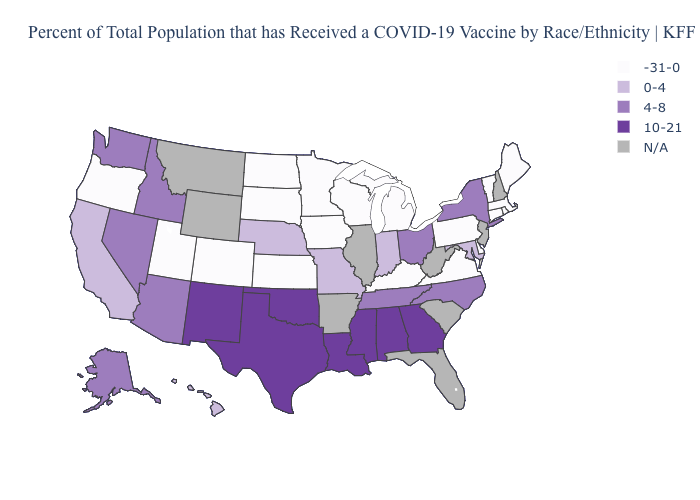Name the states that have a value in the range 4-8?
Answer briefly. Alaska, Arizona, Idaho, Nevada, New York, North Carolina, Ohio, Tennessee, Washington. How many symbols are there in the legend?
Give a very brief answer. 5. What is the value of Michigan?
Quick response, please. -31-0. Does Colorado have the lowest value in the USA?
Concise answer only. Yes. Among the states that border New Hampshire , which have the highest value?
Write a very short answer. Maine, Massachusetts, Vermont. How many symbols are there in the legend?
Keep it brief. 5. Name the states that have a value in the range N/A?
Be succinct. Arkansas, Florida, Illinois, Montana, New Hampshire, New Jersey, South Carolina, West Virginia, Wyoming. Does Kansas have the highest value in the USA?
Write a very short answer. No. Name the states that have a value in the range -31-0?
Keep it brief. Colorado, Connecticut, Delaware, Iowa, Kansas, Kentucky, Maine, Massachusetts, Michigan, Minnesota, North Dakota, Oregon, Pennsylvania, Rhode Island, South Dakota, Utah, Vermont, Virginia, Wisconsin. What is the highest value in states that border California?
Write a very short answer. 4-8. What is the lowest value in the USA?
Keep it brief. -31-0. Which states hav the highest value in the South?
Answer briefly. Alabama, Georgia, Louisiana, Mississippi, Oklahoma, Texas. Name the states that have a value in the range N/A?
Concise answer only. Arkansas, Florida, Illinois, Montana, New Hampshire, New Jersey, South Carolina, West Virginia, Wyoming. What is the lowest value in the USA?
Give a very brief answer. -31-0. 